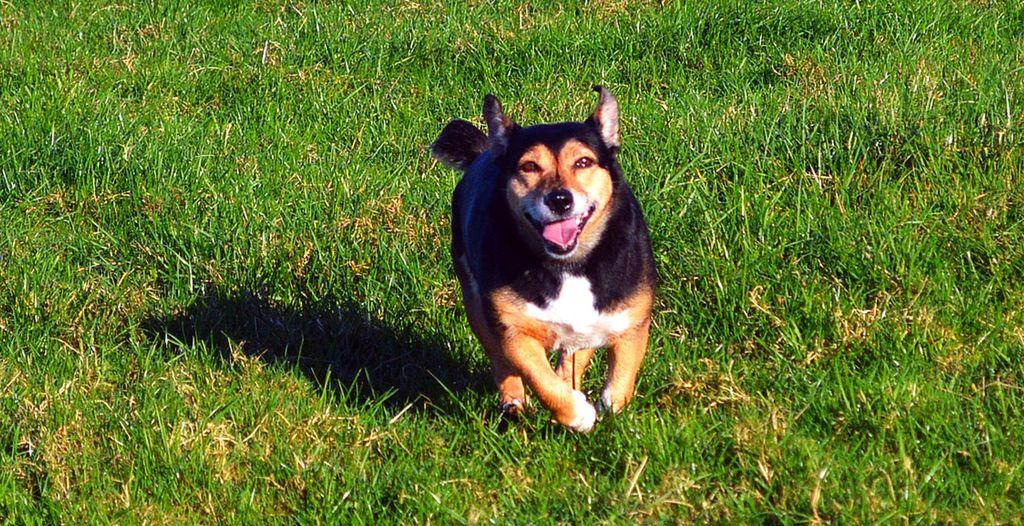What type of animal is present in the image? There is a dog in the image. What is the dog doing in the image? The dog is running on the ground. What type of terrain can be seen in the background of the image? There is grass visible in the background of the image. What type of lizards can be seen joining the dog in the image? There are no lizards present in the image, and therefore no such interaction can be observed. 